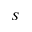Convert formula to latex. <formula><loc_0><loc_0><loc_500><loc_500>S</formula> 